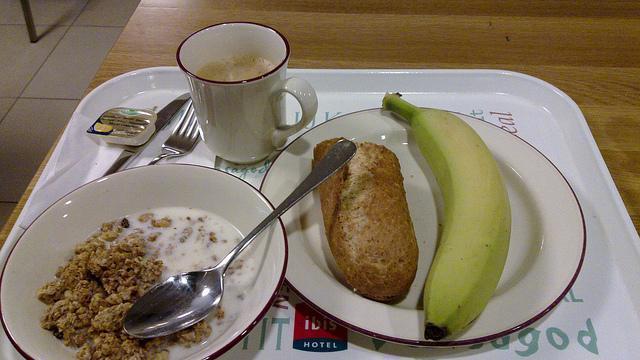What is on the plate all the way to the right?
Choose the right answer from the provided options to respond to the question.
Options: Banana, egg, apple, lemon. Banana. 